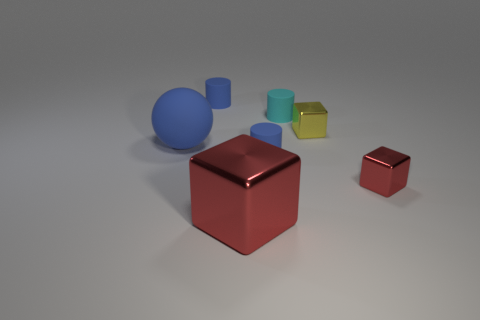Is there a cylinder of the same color as the big ball?
Give a very brief answer. Yes. Are there any small red shiny cubes to the left of the tiny metallic block behind the rubber sphere that is on the left side of the small yellow object?
Give a very brief answer. No. Is the number of small blue rubber objects that are in front of the small red metal thing less than the number of big spheres that are behind the big blue thing?
Offer a very short reply. No. The large blue object that is made of the same material as the small cyan cylinder is what shape?
Offer a terse response. Sphere. There is a blue cylinder that is right of the tiny blue cylinder that is behind the sphere on the left side of the yellow shiny thing; what size is it?
Offer a terse response. Small. Is the number of blue metal blocks greater than the number of blue matte cylinders?
Your response must be concise. No. Do the tiny object that is behind the cyan thing and the matte thing that is in front of the big blue matte object have the same color?
Provide a short and direct response. Yes. Does the blue cylinder behind the big ball have the same material as the tiny cylinder in front of the big matte object?
Provide a short and direct response. Yes. How many cylinders have the same size as the matte ball?
Your answer should be compact. 0. Are there fewer tiny cyan rubber cylinders than big metal spheres?
Provide a succinct answer. No. 